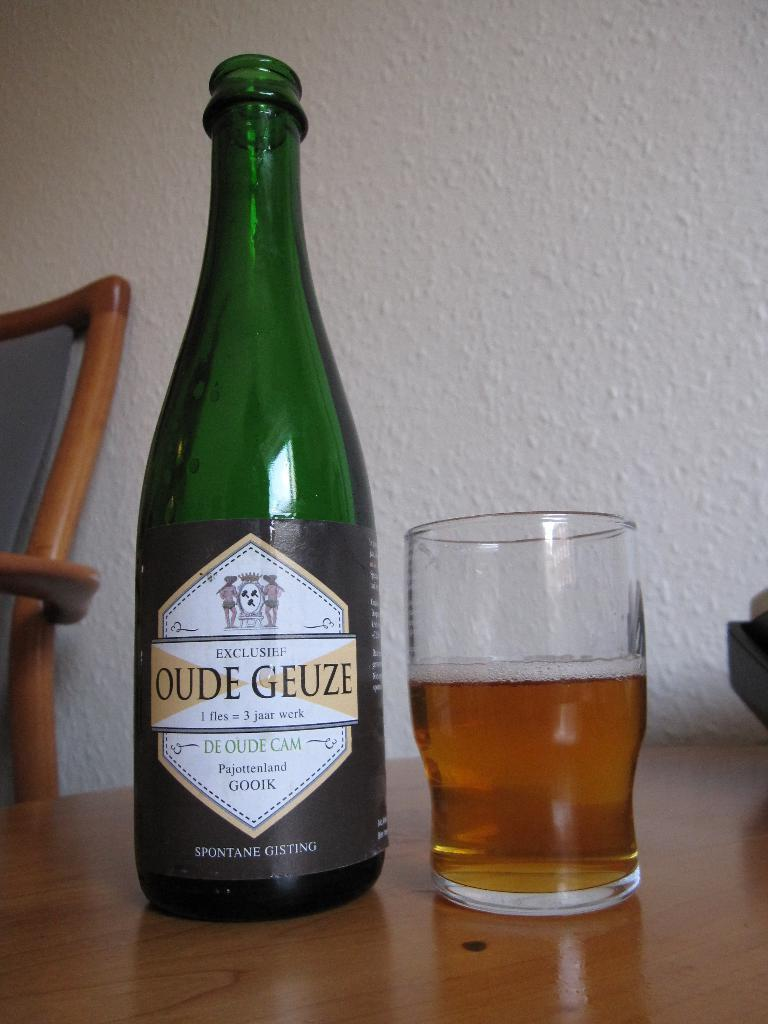Provide a one-sentence caption for the provided image. A bottle of Oude Geuze sits next to a half-full glass. 